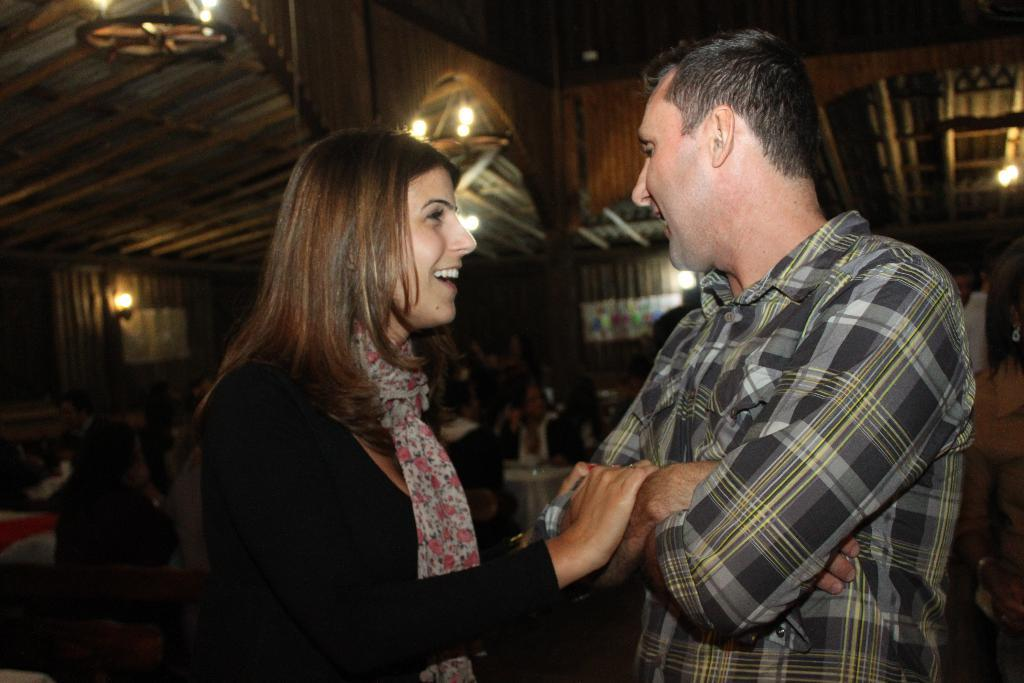How many people are in the image? There are two persons in the center of the image. What can be seen in the background of the image? There is a wooden wall in the background of the image. What is illuminating the scene in the image? There are lights visible in the image. What are the people doing in the image? There are people sitting on chairs in the image. What type of pin is the person wearing on their skirt in the image? There is no person wearing a skirt or pin in the image. 